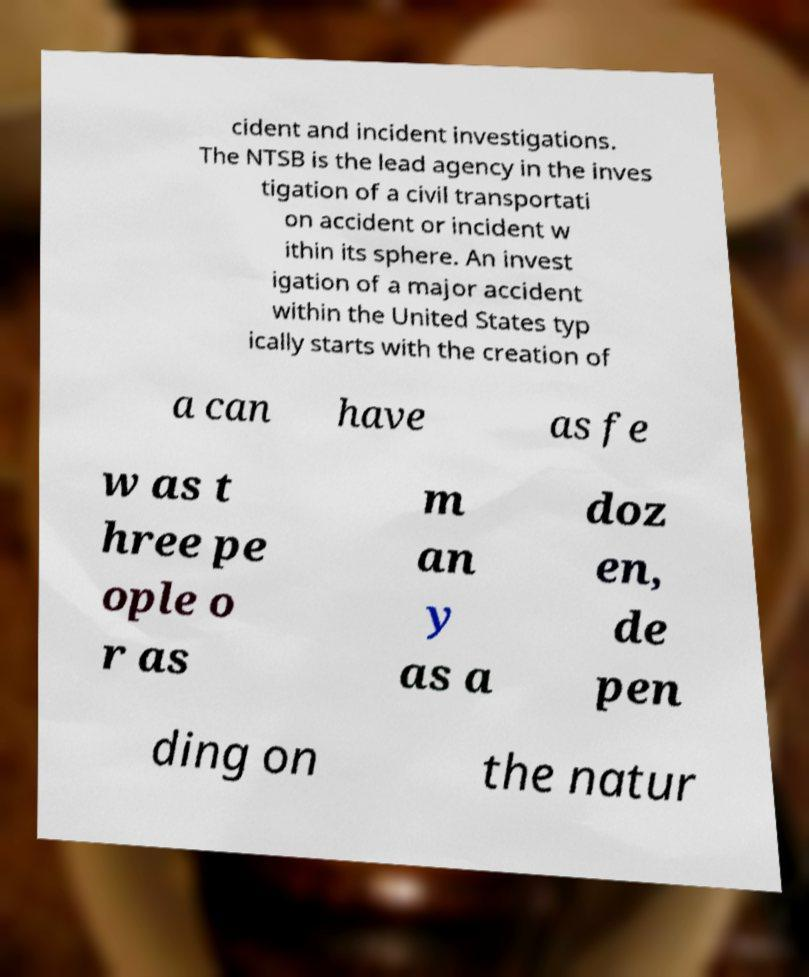Could you extract and type out the text from this image? cident and incident investigations. The NTSB is the lead agency in the inves tigation of a civil transportati on accident or incident w ithin its sphere. An invest igation of a major accident within the United States typ ically starts with the creation of a can have as fe w as t hree pe ople o r as m an y as a doz en, de pen ding on the natur 